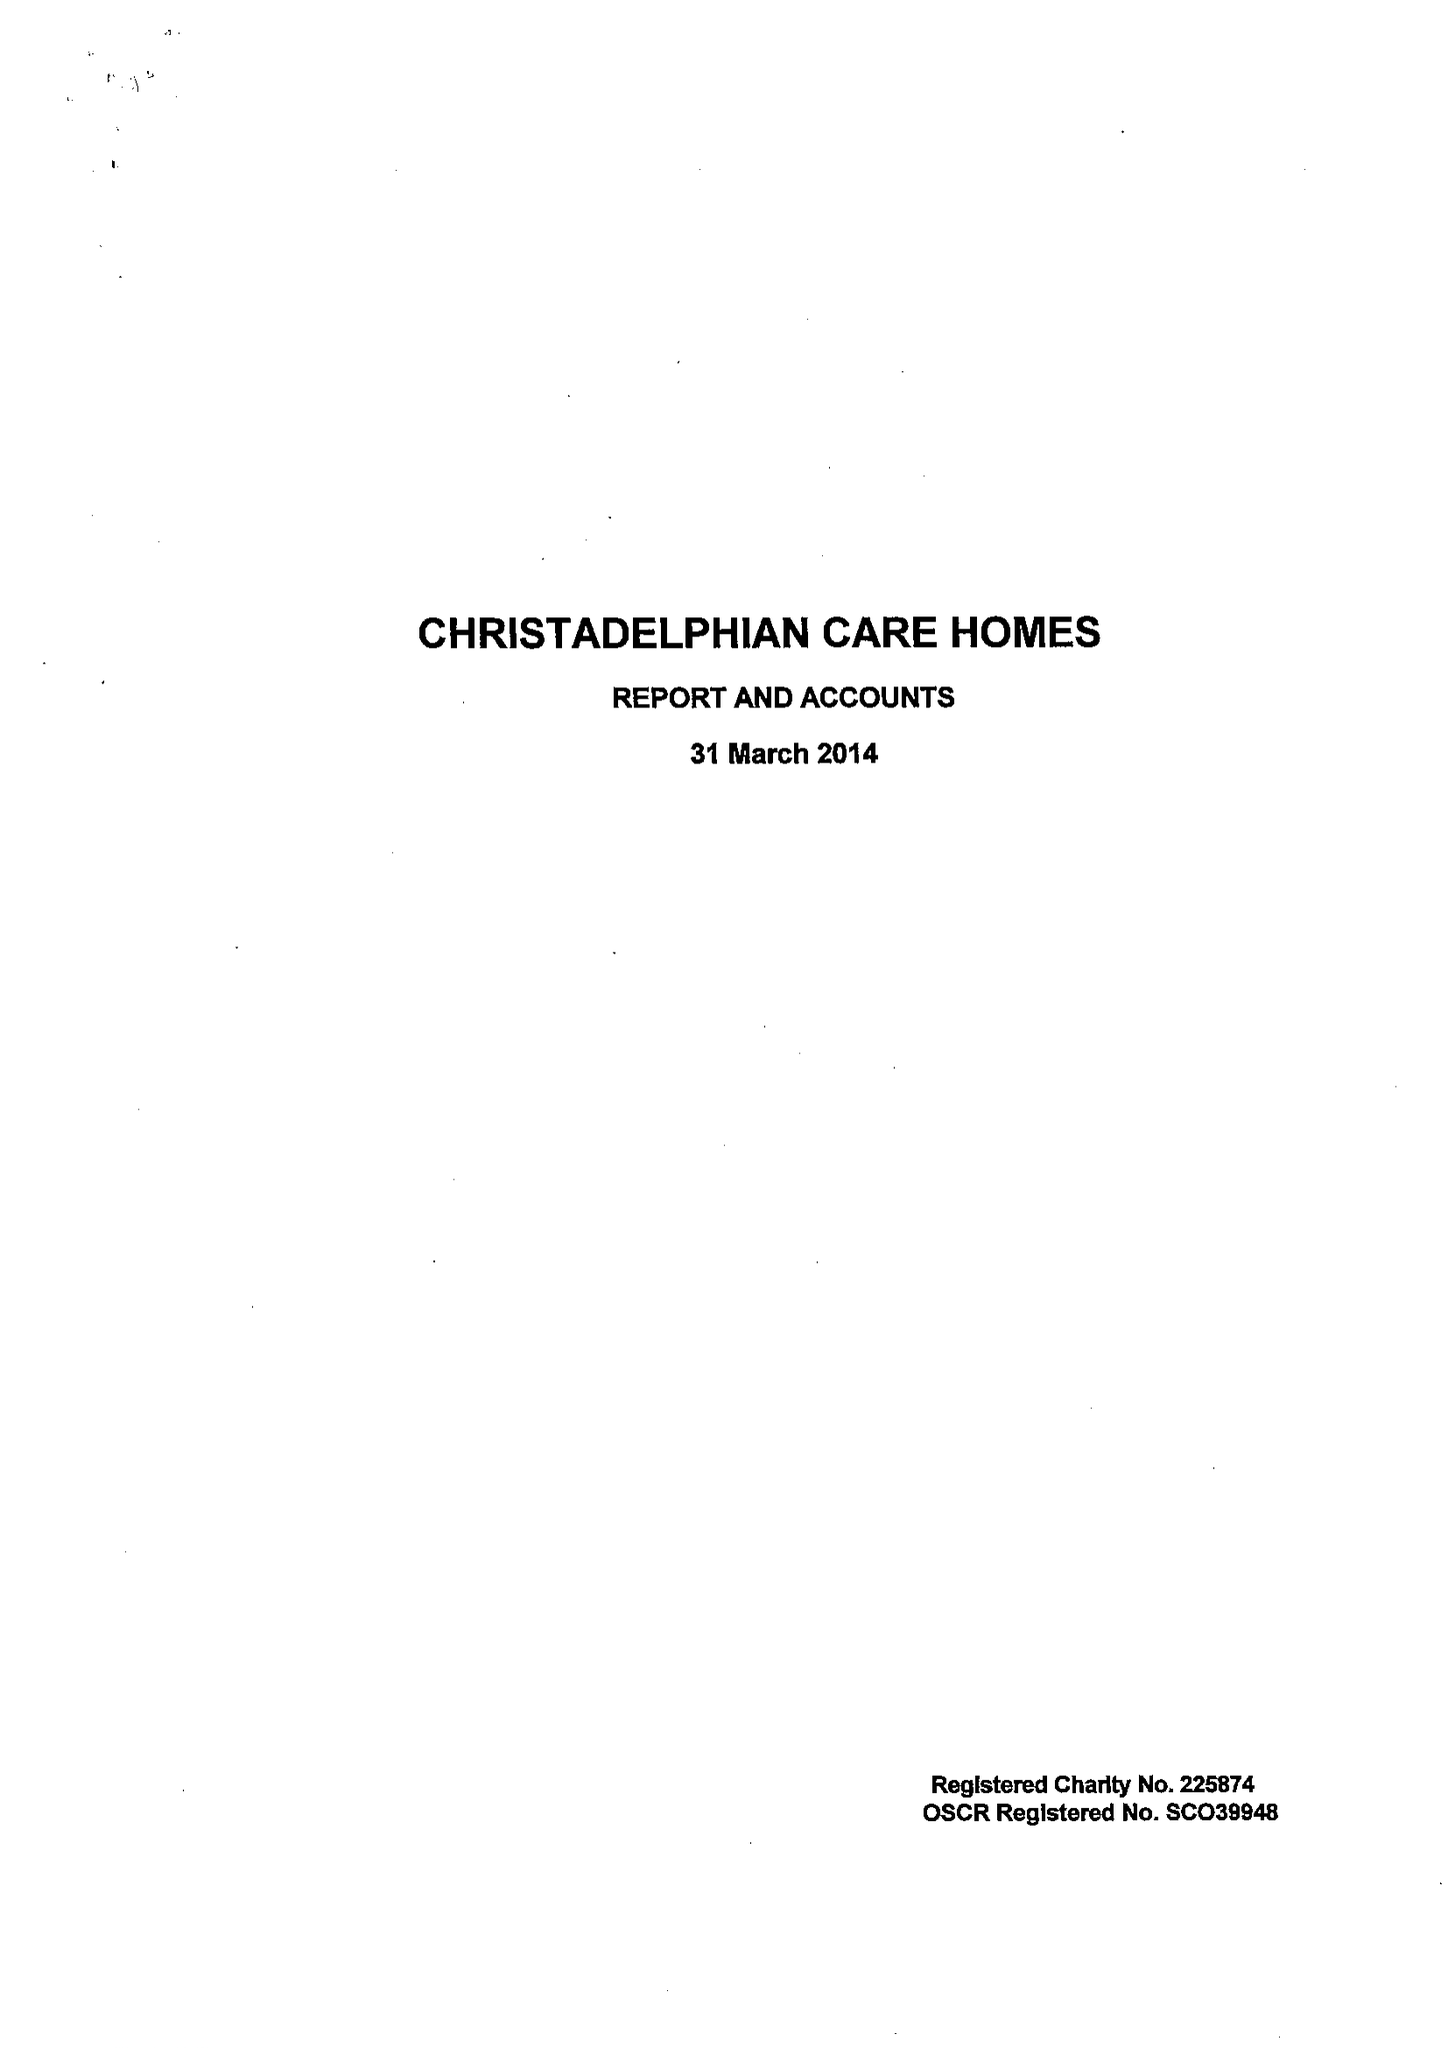What is the value for the report_date?
Answer the question using a single word or phrase. 2014-03-31 